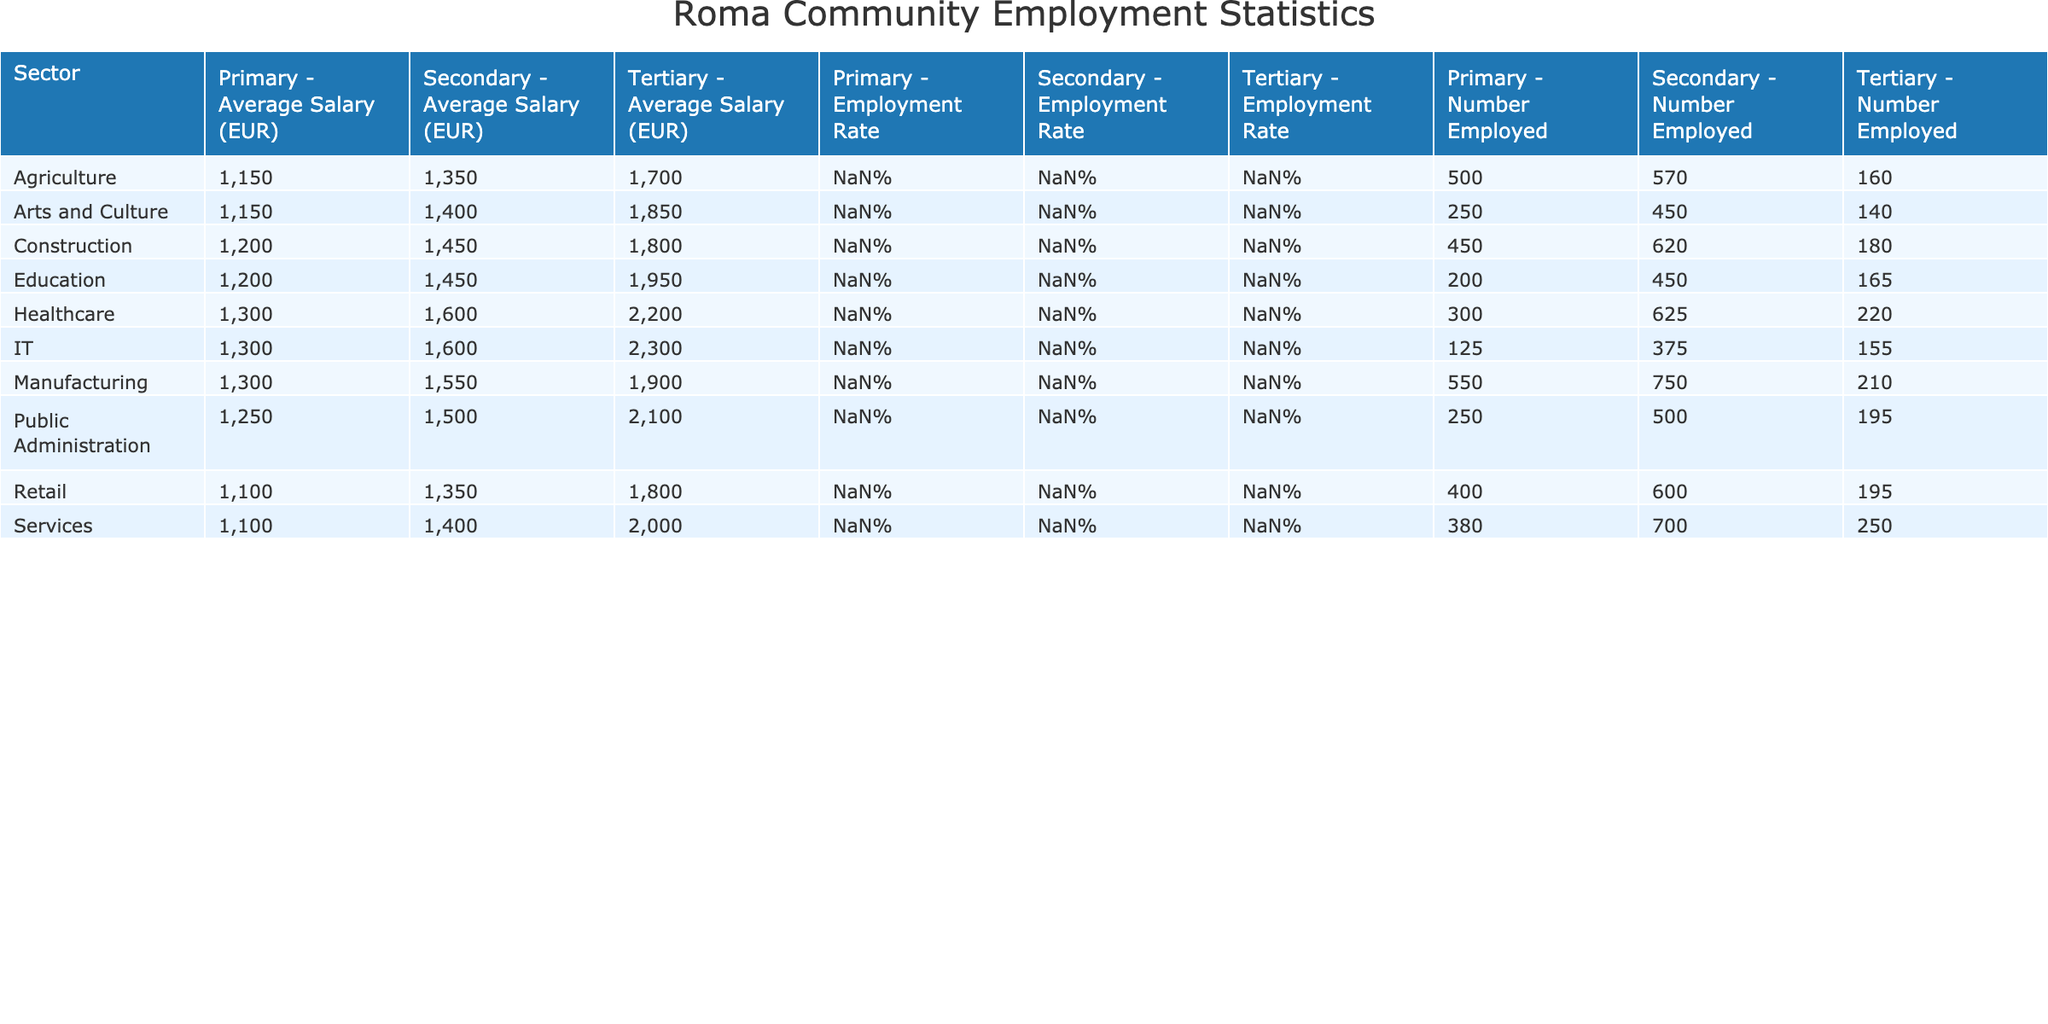What is the employment rate for the Services sector at the Tertiary education level? According to the table, the employment rate specifically for the Services sector at the Tertiary education level is listed as 45%.
Answer: 45% Which sector has the highest average salary for employees with Secondary education? By analyzing the data, we see that the average salary across different sectors for Secondary education is as follows: Construction 1450, Manufacturing 1550, Services 1400, Agriculture 1350, Public Administration 1500, Healthcare 1600, Education 1450, Retail 1350, IT 1600, Arts and Culture 1400. The highest average salary of 1600 EUR can be found in the Healthcare and IT sectors.
Answer: 1600 EUR If we add the number of employed individuals in Agriculture and Manufacturing with Tertiary education, what is the total? The number of employed individuals in Agriculture at Tertiary education level is 160 and in Manufacturing at Tertiary education level is 210. Therefore, the total number of employed individuals is 160 + 210 = 370.
Answer: 370 Is the employment rate for Primary education in the Public Administration sector greater than that in the Services sector? The employment rate for Primary education in the Public Administration sector is 10% while for the Services sector it is 15%. Since 15% > 10%, the statement is true.
Answer: Yes What is the difference in Average Salary (EUR) between employees with Tertiary education in Healthcare and those in Construction? The average salary for Healthcare with Tertiary education is 2200 EUR and for Construction, it is 1800 EUR. The difference is calculated as 2200 - 1800 = 400 EUR.
Answer: 400 EUR What is the total number of employed individuals across all sectors for Secondary education? To find this, we sum the number of employees with Secondary education in each sector: Construction 620, Manufacturing 750, Services 700, Agriculture 570, Public Administration 500, Healthcare 625, Education 450, Retail 600, IT 375, Arts and Culture 450. The total is 620 + 750 + 700 + 570 + 500 + 625 + 450 + 600 + 375 + 450 = 5,090.
Answer: 5090 Which education level has the lowest employment rate in the Retail sector? The Retail sector's employment rates based on education levels are: Primary 16%, Secondary 24%, Tertiary 35%. The lowest rate among these is 16% for Primary education.
Answer: 16% Which sector has more employees with Tertiary education: Services or Agriculture? The number of employed individuals in the Services sector with Tertiary education is 250, while in Agriculture it is 160. Since 250 > 160, the Services sector has more employees with Tertiary education.
Answer: Services sector What is the average employment rate for Tertiary education across all sectors? The employment rates at Tertiary education across the sectors are: Construction 32%, Manufacturing 38%, Services 45%, Agriculture 28%, Public Administration 35%, Healthcare 40%, Education 30%, Retail 35%, IT 28%, Arts and Culture 25%. The average employment rate is calculated as (32 + 38 + 45 + 28 + 35 + 40 + 30 + 35 + 28 + 25) / 10 = 34.3%.
Answer: 34.3% 